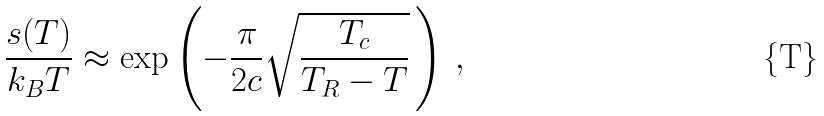Convert formula to latex. <formula><loc_0><loc_0><loc_500><loc_500>\frac { s ( T ) } { k _ { B } T } \approx \exp \left ( - \frac { \pi } { 2 c } \sqrt { \frac { T _ { c } } { T _ { R } - T } } \, \right ) \, ,</formula> 